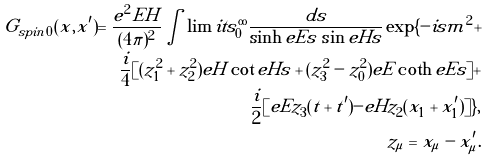Convert formula to latex. <formula><loc_0><loc_0><loc_500><loc_500>G _ { s p i n \, 0 } ( x , x ^ { \prime } ) = \frac { e ^ { 2 } E H } { ( 4 \pi ) ^ { 2 } } \int \lim i t s _ { 0 } ^ { \infty } \frac { d s } { \sinh e E s \, \sin e H s } \exp \{ - i s m ^ { 2 } + \\ \frac { i } { 4 } [ ( z _ { 1 } ^ { 2 } + z _ { 2 } ^ { 2 } ) e H \cot e H s + ( z _ { 3 } ^ { 2 } - z _ { 0 } ^ { 2 } ) e E \coth e E s ] + \\ \frac { i } { 2 } [ e E z _ { 3 } ( t + t ^ { \prime } ) - e H z _ { 2 } ( x _ { 1 } + x ^ { \prime } _ { 1 } ) ] \} , \\ z _ { \mu } = x _ { \mu } - x ^ { \prime } _ { \mu } .</formula> 